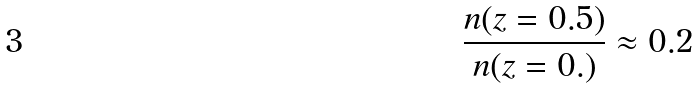Convert formula to latex. <formula><loc_0><loc_0><loc_500><loc_500>\frac { n ( z = 0 . 5 ) } { n ( z = 0 . ) } \approx 0 . 2</formula> 